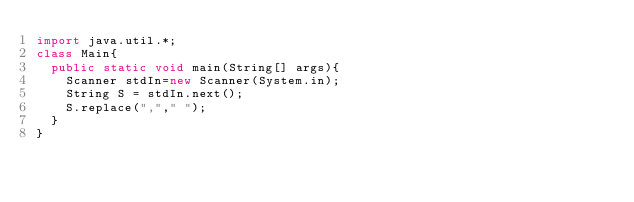Convert code to text. <code><loc_0><loc_0><loc_500><loc_500><_Java_>import java.util.*;
class Main{
  public static void main(String[] args){
    Scanner stdIn=new Scanner(System.in);
    String S = stdIn.next();
    S.replace(","," ");
  }
}</code> 